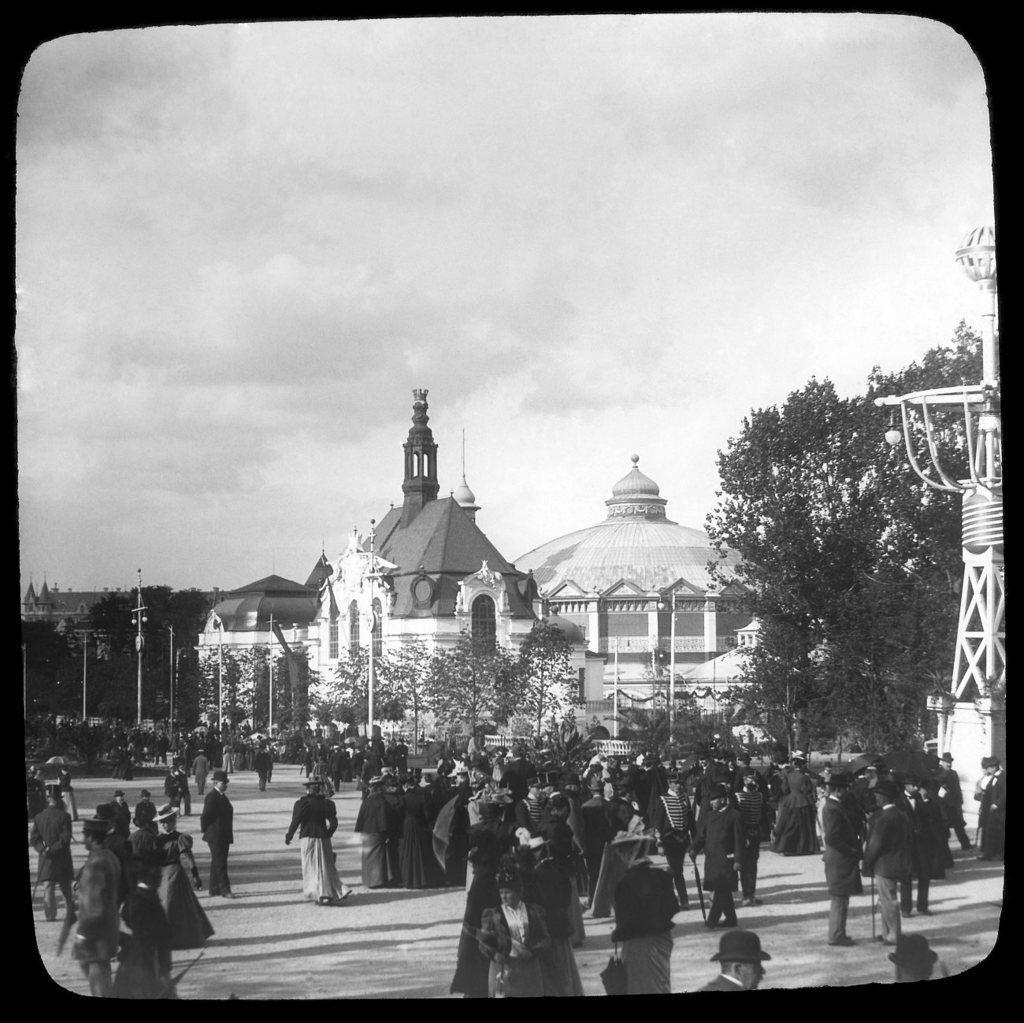Describe this image in one or two sentences. This is a black and white image and it is edited. At the bottom, I can see a crowd of people standing on the ground. In the background there are buildings, trees and poles. At the top of the image I can see the sky. 